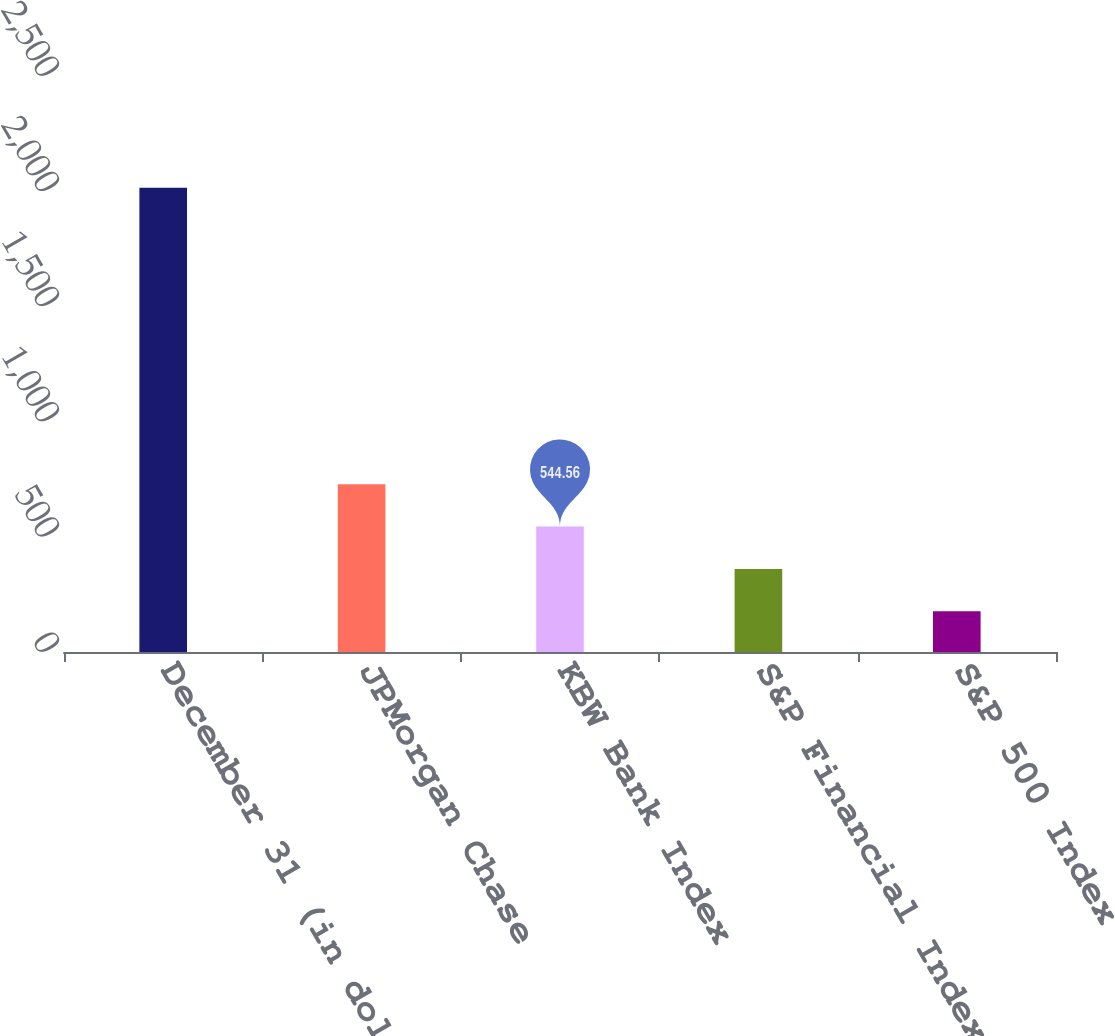<chart> <loc_0><loc_0><loc_500><loc_500><bar_chart><fcel>December 31 (in dollars)<fcel>JPMorgan Chase<fcel>KBW Bank Index<fcel>S&P Financial Index<fcel>S&P 500 Index<nl><fcel>2015<fcel>728.37<fcel>544.56<fcel>360.75<fcel>176.95<nl></chart> 